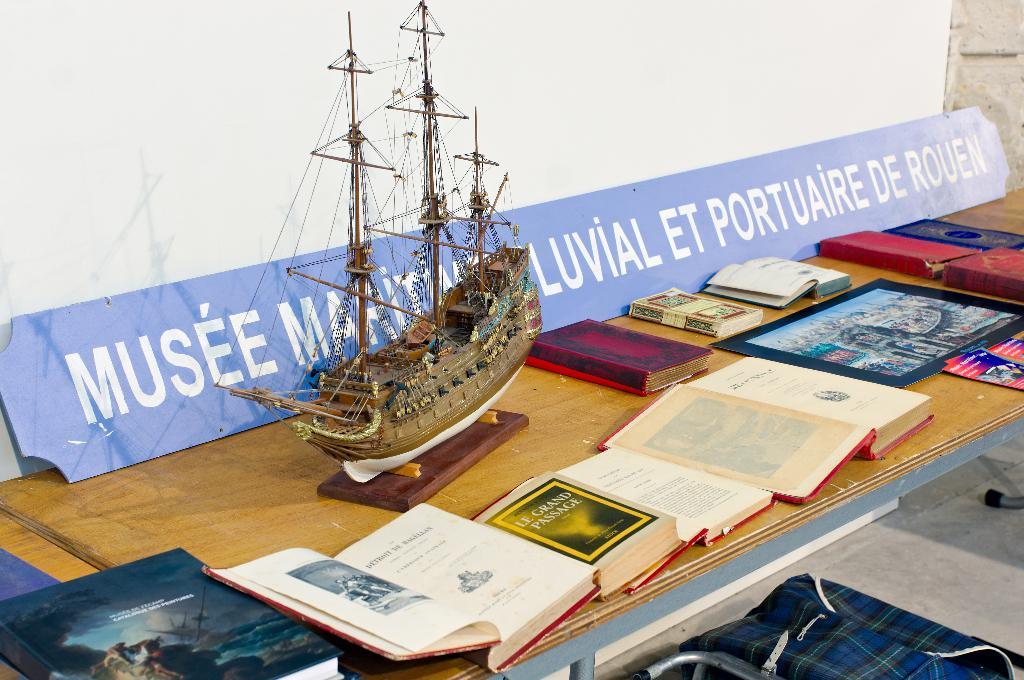What is the last word on the banner?
Your response must be concise. Rouen. 